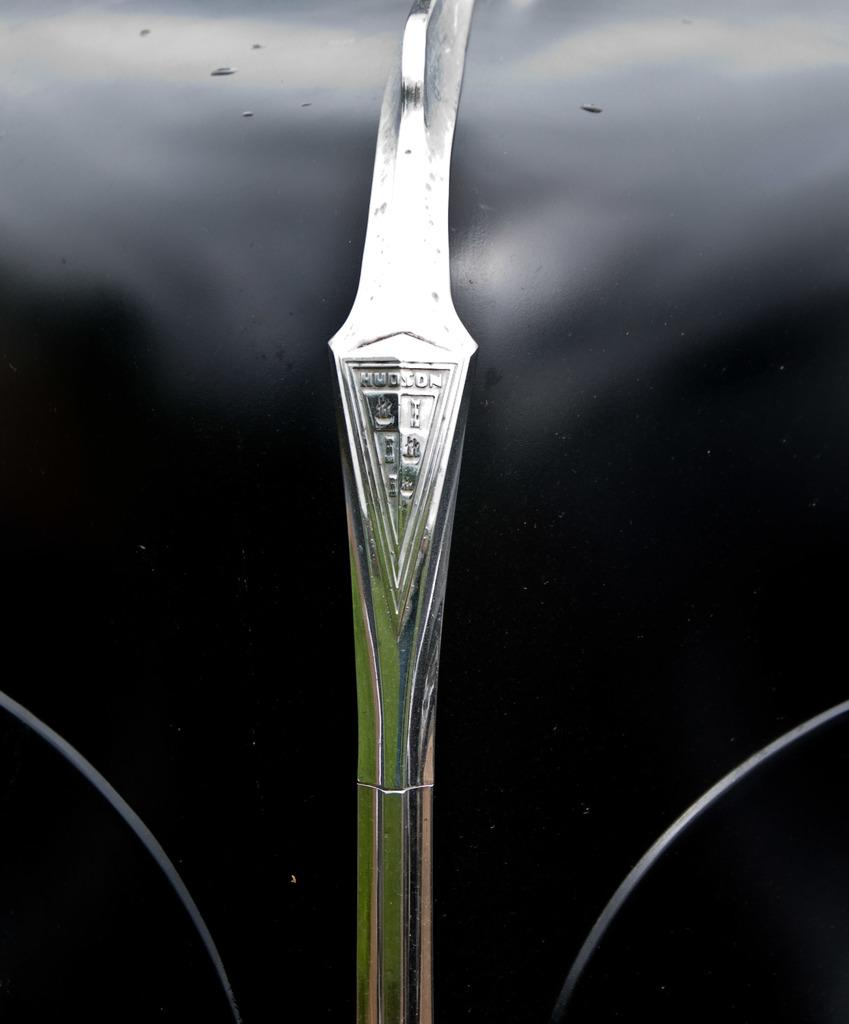What is the color of the surface in the image? The surface in the image is black. What is placed on the black surface? There is a silver object on the black surface. What can be seen on the silver object? There is writing on the silver object. What type of food is being served in the alley behind the silver object? There is no food or alley present in the image; it only features a black surface with a silver object on it. 